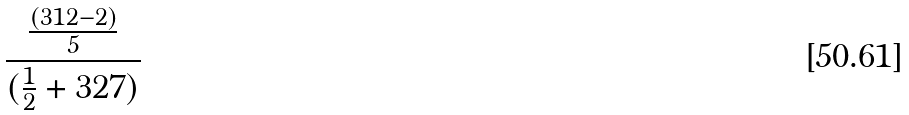<formula> <loc_0><loc_0><loc_500><loc_500>\frac { \frac { ( 3 1 2 - 2 ) } { 5 } } { ( \frac { 1 } { 2 } + 3 2 7 ) }</formula> 